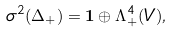<formula> <loc_0><loc_0><loc_500><loc_500>\sigma ^ { 2 } ( \Delta _ { + } ) = { \mathbf 1 } \oplus \Lambda ^ { 4 } _ { + } ( V ) ,</formula> 